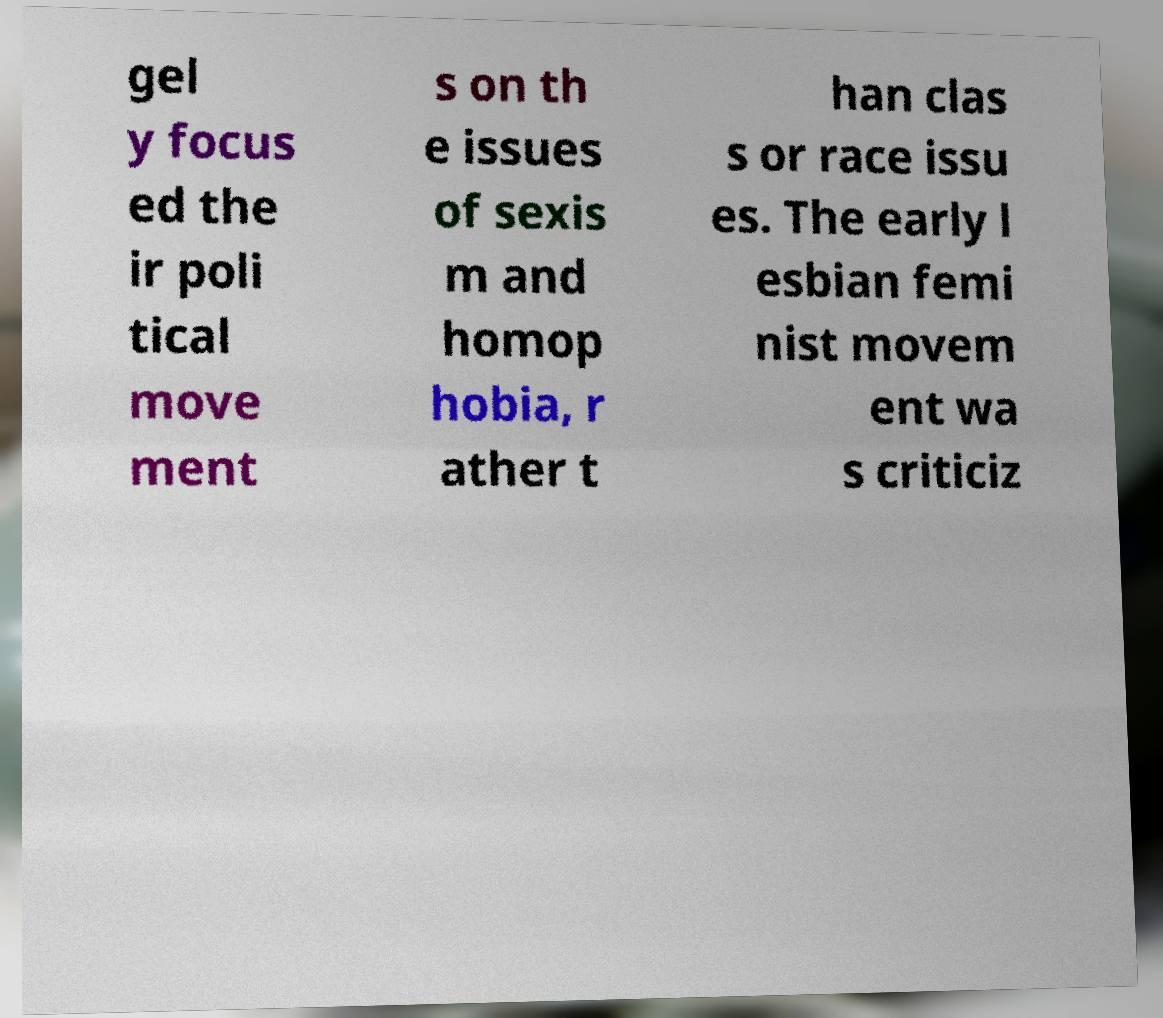Please read and relay the text visible in this image. What does it say? gel y focus ed the ir poli tical move ment s on th e issues of sexis m and homop hobia, r ather t han clas s or race issu es. The early l esbian femi nist movem ent wa s criticiz 